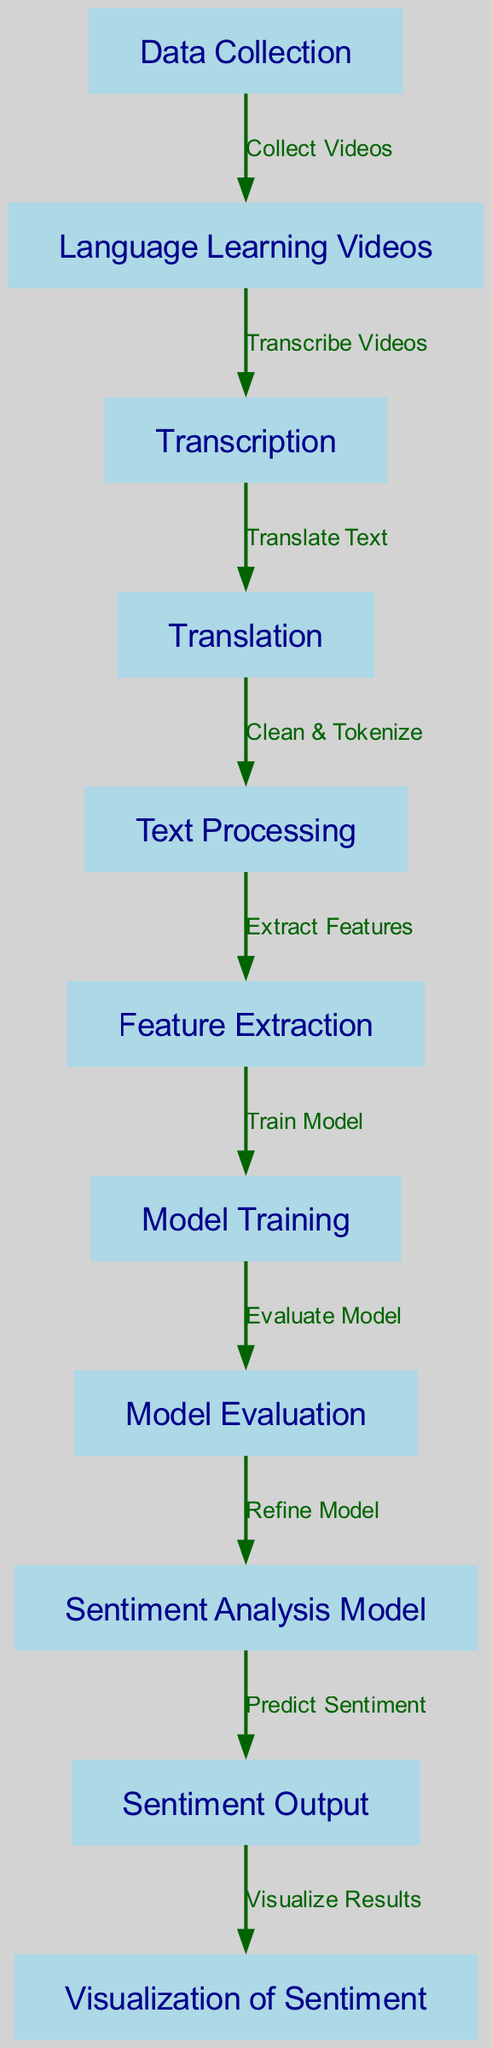What is the first step in the diagram? The first step in the diagram is "Data Collection," which is the initial node that gathers all the necessary data for further processing.
Answer: Data Collection How many nodes are there in the diagram? By counting all the unique nodes listed in the diagram, there are a total of 11 nodes involved in the workflow, from data collection to visualization.
Answer: 11 What is the last node that outputs results? The last node that outputs results is "Visualization of Sentiment," which displays the outcomes of the sentiment analysis to the users.
Answer: Visualization of Sentiment What connects "Translation" to "Text Processing"? "Translation" is connected to "Text Processing" by the edge labeled "Clean & Tokenize," indicating that the output of translation is processed to prepare it for feature extraction.
Answer: Clean & Tokenize In which node is the model refined? The model is refined in the "Model Evaluation" node, where the performance of the model is assessed, allowing for adjustments to be made for better accuracy.
Answer: Model Evaluation What step follows the "Feature Extraction" node? Following "Feature Extraction," the next step in the diagram is "Model Training," where the extracted features are used to train the sentiment analysis model.
Answer: Model Training Which two nodes are connected by the edge labeled "Predict Sentiment"? The nodes connected by the edge labeled "Predict Sentiment" are "Sentiment Analysis Model" and "Sentiment Output," indicating that the analysis leads to predicting the sentiment.
Answer: Sentiment Analysis Model, Sentiment Output What is the purpose of the "Transcription" node? The purpose of the "Transcription" node is to convert spoken content from the videos into written text, providing a textual format for translation and further analysis.
Answer: Convert spoken content to written text Which node indicates the extraction of features? The node that indicates the extraction of features is "Feature Extraction," where relevant information is gathered from the processed text for model training.
Answer: Feature Extraction 